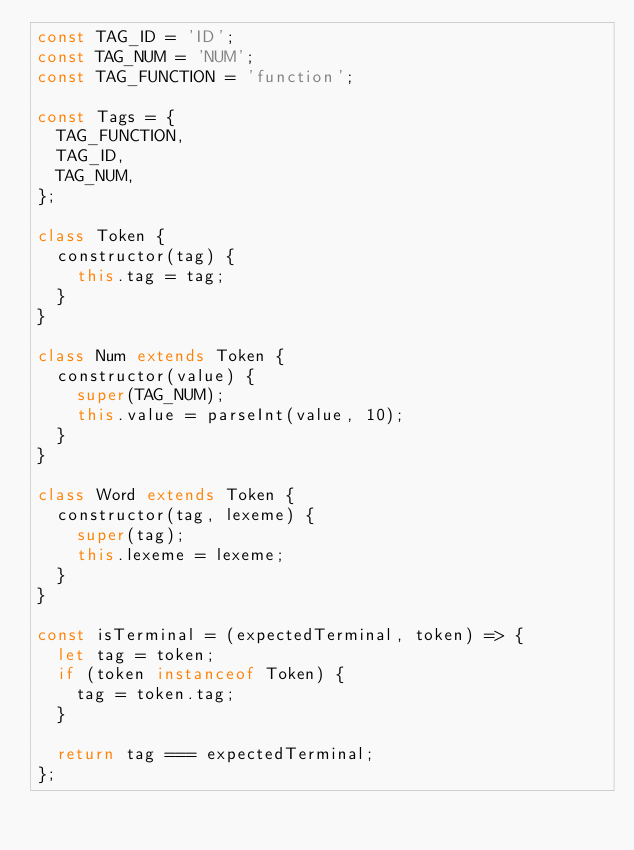<code> <loc_0><loc_0><loc_500><loc_500><_JavaScript_>const TAG_ID = 'ID';
const TAG_NUM = 'NUM';
const TAG_FUNCTION = 'function';

const Tags = {
  TAG_FUNCTION,
  TAG_ID,
  TAG_NUM,
};

class Token {
  constructor(tag) {
    this.tag = tag;
  }
}

class Num extends Token {
  constructor(value) {
    super(TAG_NUM);
    this.value = parseInt(value, 10);
  }
}

class Word extends Token {
  constructor(tag, lexeme) {
    super(tag);
    this.lexeme = lexeme;
  }
}

const isTerminal = (expectedTerminal, token) => {
  let tag = token;
  if (token instanceof Token) {
    tag = token.tag;
  }

  return tag === expectedTerminal;
};</code> 